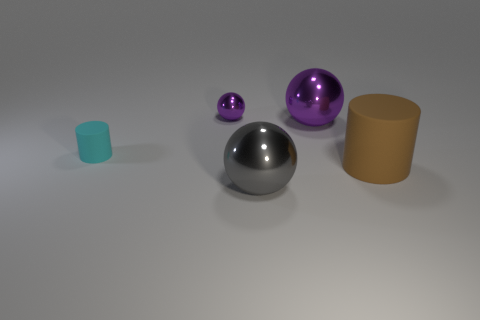How big is the purple shiny sphere on the right side of the purple shiny ball on the left side of the gray sphere?
Give a very brief answer. Large. What is the material of the other thing that is the same size as the cyan thing?
Your response must be concise. Metal. How many other things are the same size as the cyan cylinder?
Make the answer very short. 1. How many blocks are either big yellow things or large gray things?
Keep it short and to the point. 0. Is there anything else that is made of the same material as the cyan object?
Offer a terse response. Yes. There is a large object that is in front of the rubber cylinder on the right side of the metallic sphere that is in front of the tiny cyan rubber cylinder; what is its material?
Ensure brevity in your answer.  Metal. There is another thing that is the same color as the small metal object; what is it made of?
Offer a terse response. Metal. How many cyan cylinders are the same material as the tiny purple thing?
Your answer should be very brief. 0. Does the rubber cylinder on the right side of the cyan rubber cylinder have the same size as the tiny purple sphere?
Offer a very short reply. No. The cylinder that is the same material as the brown thing is what color?
Your answer should be very brief. Cyan. 